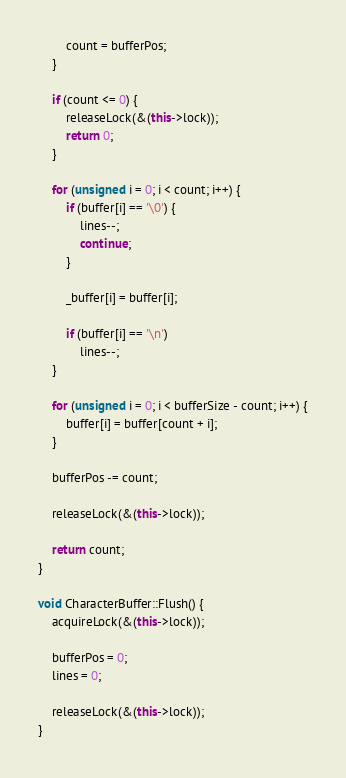Convert code to text. <code><loc_0><loc_0><loc_500><loc_500><_C++_>        count = bufferPos;
    }

    if (count <= 0) {
        releaseLock(&(this->lock));
        return 0;
    }

    for (unsigned i = 0; i < count; i++) {
        if (buffer[i] == '\0') {
            lines--;
            continue;
        }

        _buffer[i] = buffer[i];

        if (buffer[i] == '\n')
            lines--;
    }

    for (unsigned i = 0; i < bufferSize - count; i++) {
        buffer[i] = buffer[count + i];
    }

    bufferPos -= count;

    releaseLock(&(this->lock));

    return count;
}

void CharacterBuffer::Flush() {
    acquireLock(&(this->lock));

    bufferPos = 0;
    lines = 0;

    releaseLock(&(this->lock));
}</code> 